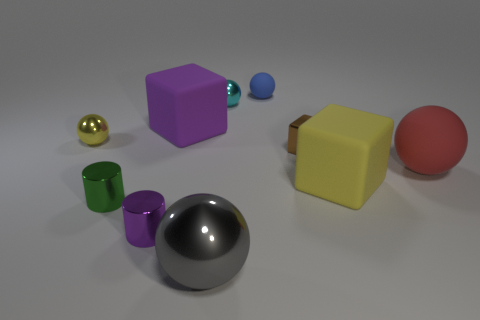Which objects appear to have a reflective surface? The objects with reflective surfaces include the silver chrome sphere in the front and the gold-colored sphere towards the back. 